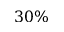Convert formula to latex. <formula><loc_0><loc_0><loc_500><loc_500>3 0 \%</formula> 